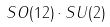Convert formula to latex. <formula><loc_0><loc_0><loc_500><loc_500>S O ( 1 2 ) \cdot S U ( 2 )</formula> 